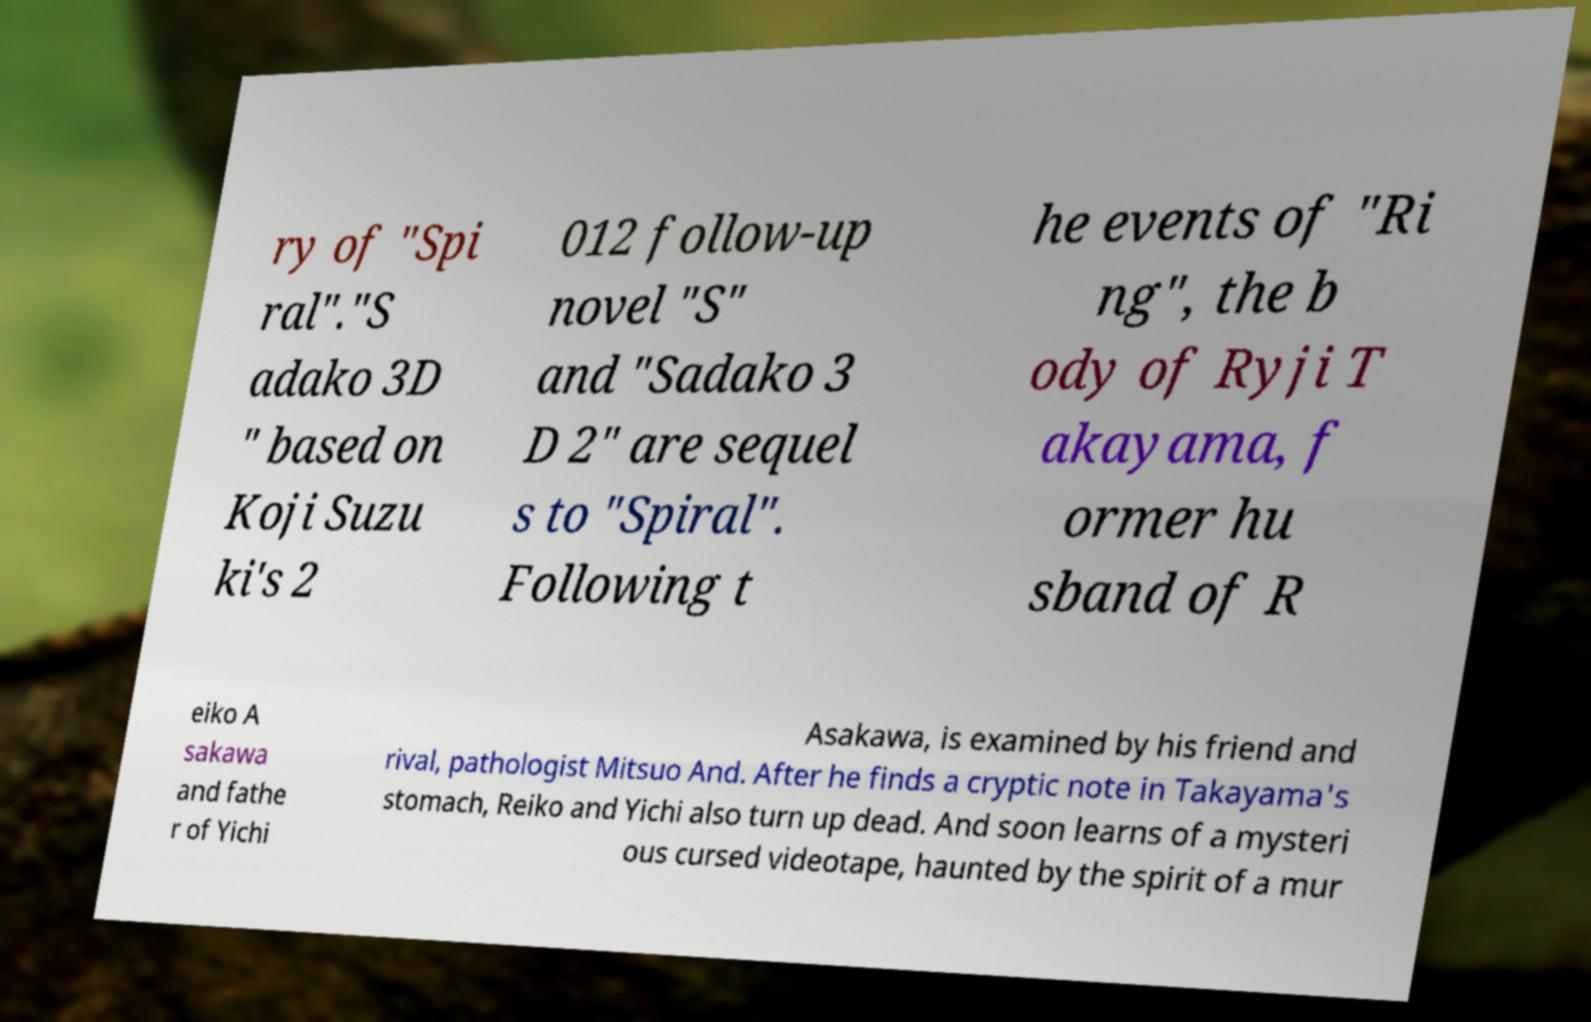For documentation purposes, I need the text within this image transcribed. Could you provide that? ry of "Spi ral"."S adako 3D " based on Koji Suzu ki's 2 012 follow-up novel "S" and "Sadako 3 D 2" are sequel s to "Spiral". Following t he events of "Ri ng", the b ody of Ryji T akayama, f ormer hu sband of R eiko A sakawa and fathe r of Yichi Asakawa, is examined by his friend and rival, pathologist Mitsuo And. After he finds a cryptic note in Takayama's stomach, Reiko and Yichi also turn up dead. And soon learns of a mysteri ous cursed videotape, haunted by the spirit of a mur 